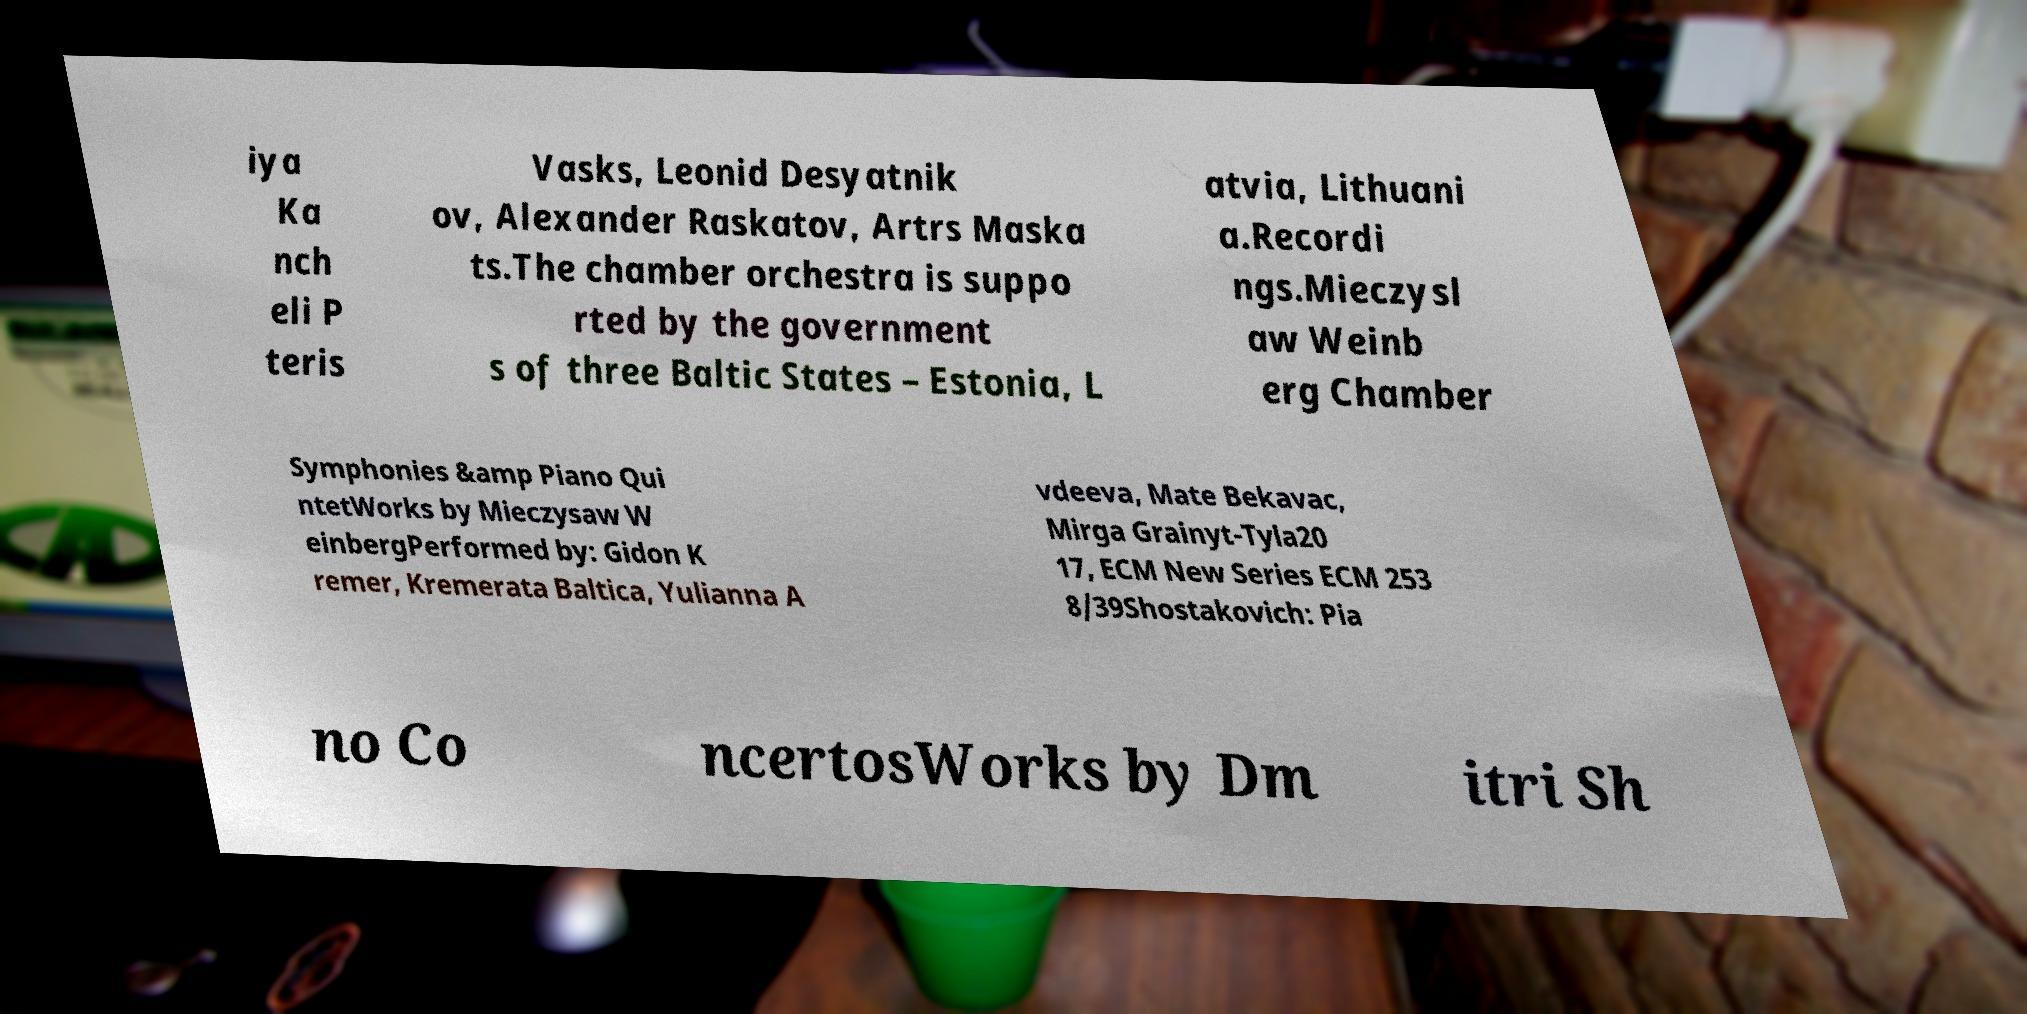What messages or text are displayed in this image? I need them in a readable, typed format. iya Ka nch eli P teris Vasks, Leonid Desyatnik ov, Alexander Raskatov, Artrs Maska ts.The chamber orchestra is suppo rted by the government s of three Baltic States – Estonia, L atvia, Lithuani a.Recordi ngs.Mieczysl aw Weinb erg Chamber Symphonies &amp Piano Qui ntetWorks by Mieczysaw W einbergPerformed by: Gidon K remer, Kremerata Baltica, Yulianna A vdeeva, Mate Bekavac, Mirga Grainyt-Tyla20 17, ECM New Series ECM 253 8/39Shostakovich: Pia no Co ncertosWorks by Dm itri Sh 